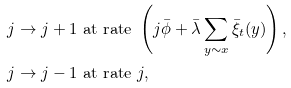Convert formula to latex. <formula><loc_0><loc_0><loc_500><loc_500>j \to j + 1 & \text { at rate } \left ( j \bar { \phi } + \bar { \lambda } \sum _ { y \sim x } \bar { \xi } _ { t } ( y ) \right ) , \\ j \to j - 1 & \text { at rate } j ,</formula> 